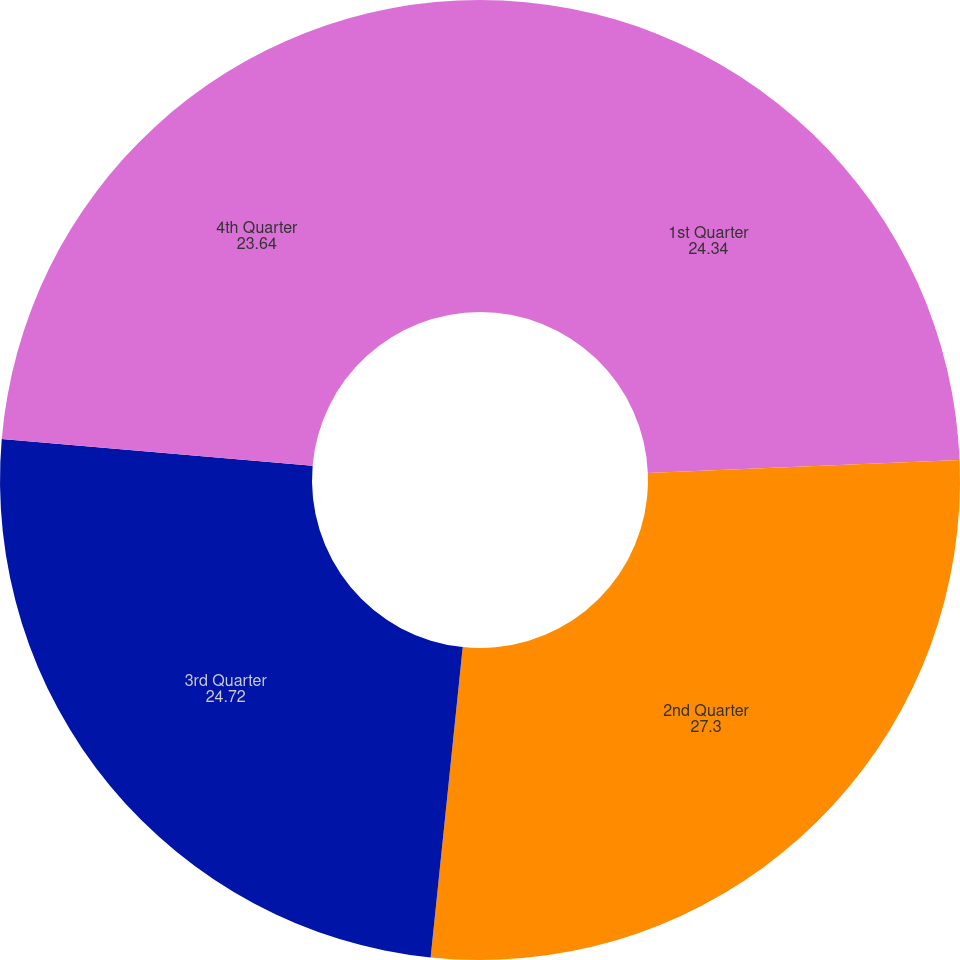Convert chart to OTSL. <chart><loc_0><loc_0><loc_500><loc_500><pie_chart><fcel>1st Quarter<fcel>2nd Quarter<fcel>3rd Quarter<fcel>4th Quarter<nl><fcel>24.34%<fcel>27.3%<fcel>24.72%<fcel>23.64%<nl></chart> 